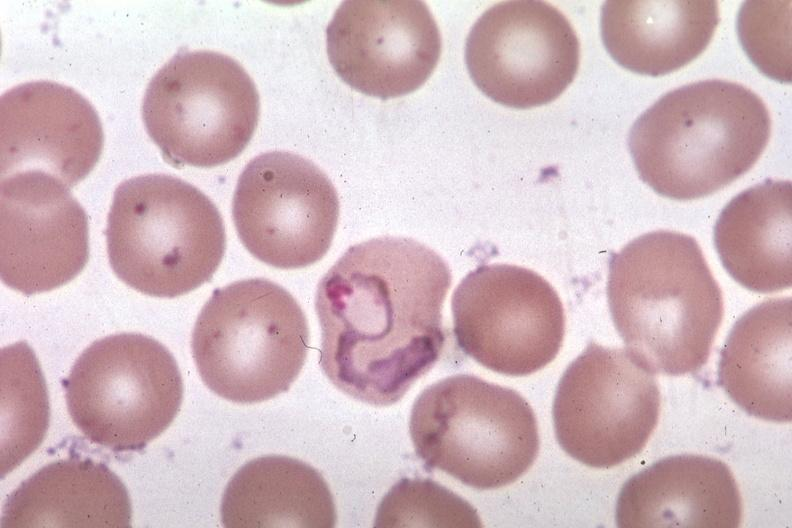what is present?
Answer the question using a single word or phrase. Blood 